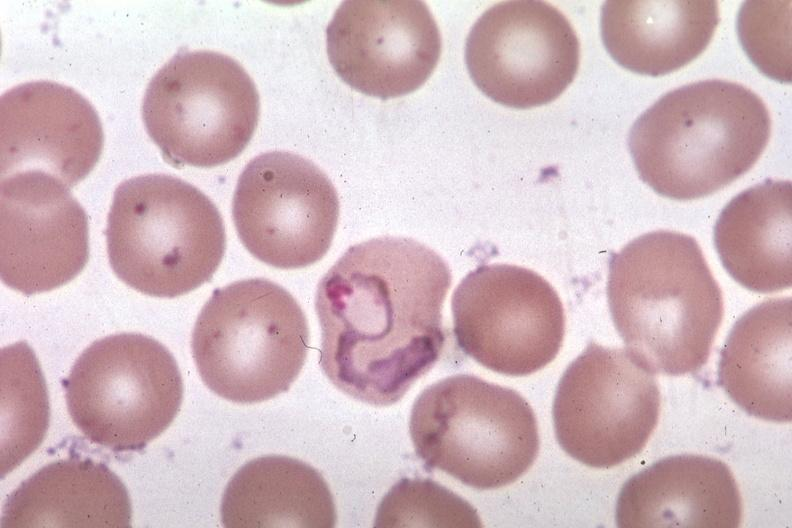what is present?
Answer the question using a single word or phrase. Blood 